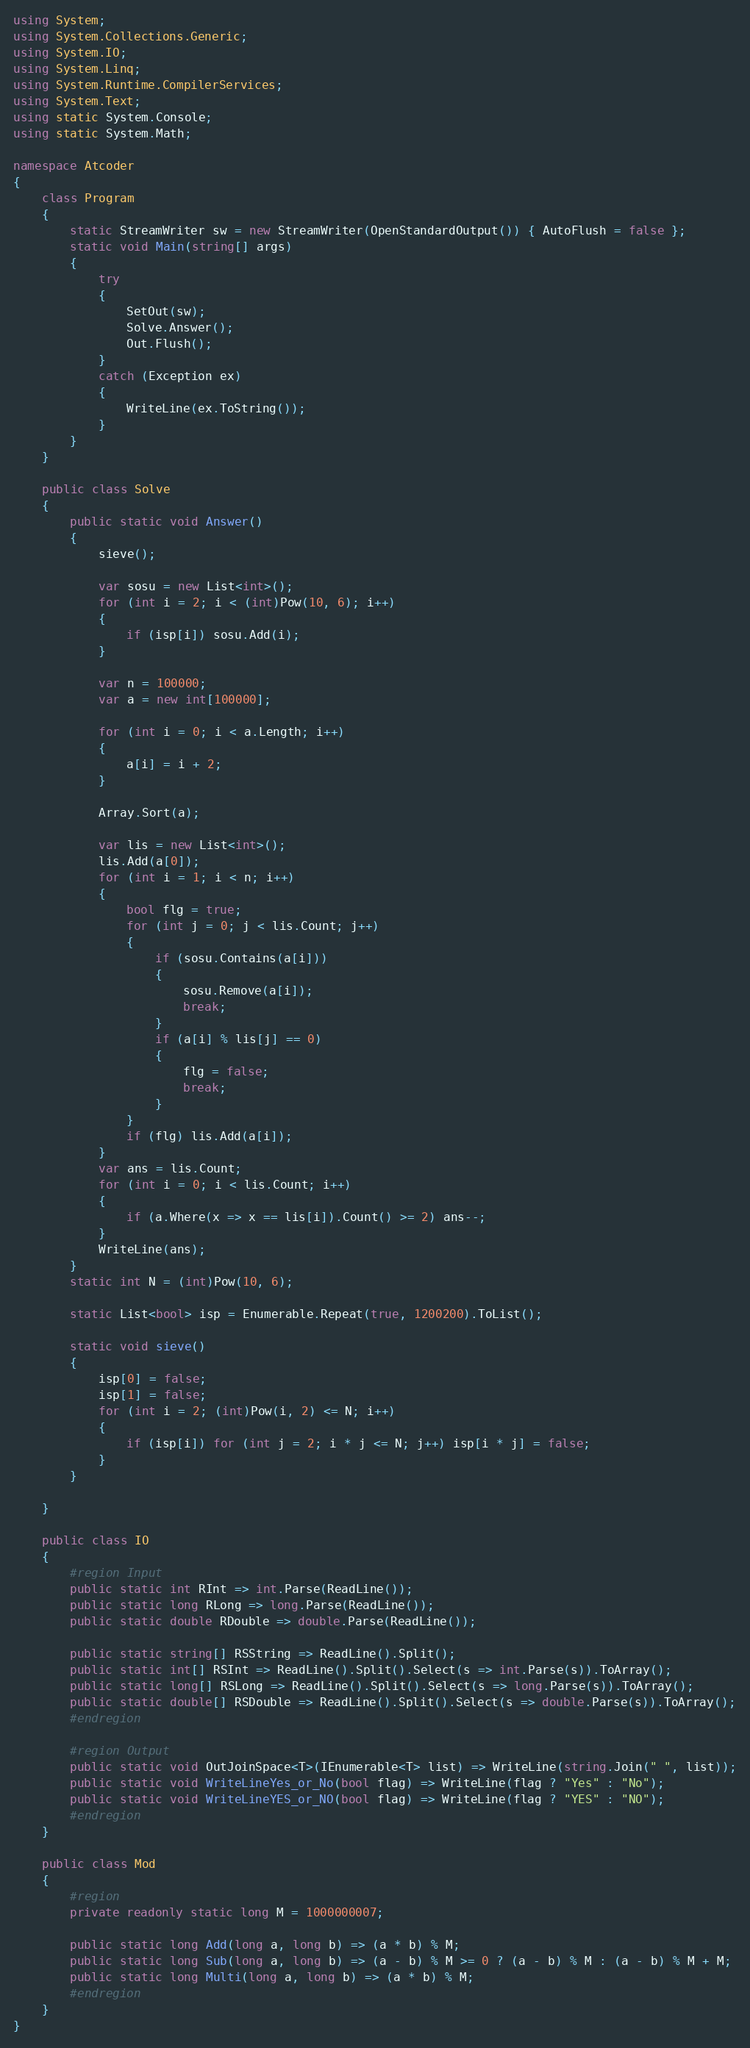Convert code to text. <code><loc_0><loc_0><loc_500><loc_500><_C#_>using System;
using System.Collections.Generic;
using System.IO;
using System.Linq;
using System.Runtime.CompilerServices;
using System.Text;
using static System.Console;
using static System.Math;

namespace Atcoder
{
    class Program
    {
        static StreamWriter sw = new StreamWriter(OpenStandardOutput()) { AutoFlush = false };
        static void Main(string[] args)
        {
            try
            {
                SetOut(sw);
                Solve.Answer();
                Out.Flush();
            }
            catch (Exception ex)
            {
                WriteLine(ex.ToString());
            }
        }
    }

    public class Solve
    {
        public static void Answer()
        {
            sieve();

            var sosu = new List<int>();
            for (int i = 2; i < (int)Pow(10, 6); i++)
            {
                if (isp[i]) sosu.Add(i);
            }

            var n = 100000;
            var a = new int[100000];

            for (int i = 0; i < a.Length; i++)
            {
                a[i] = i + 2;
            }

            Array.Sort(a);

            var lis = new List<int>();
            lis.Add(a[0]);
            for (int i = 1; i < n; i++)
            {
                bool flg = true;
                for (int j = 0; j < lis.Count; j++)
                {
                    if (sosu.Contains(a[i]))
                    {
                        sosu.Remove(a[i]);
                        break;
                    }
                    if (a[i] % lis[j] == 0)
                    {
                        flg = false;
                        break;
                    }
                }
                if (flg) lis.Add(a[i]);
            }
            var ans = lis.Count;
            for (int i = 0; i < lis.Count; i++)
            {
                if (a.Where(x => x == lis[i]).Count() >= 2) ans--;
            }
            WriteLine(ans);
        }
        static int N = (int)Pow(10, 6);

        static List<bool> isp = Enumerable.Repeat(true, 1200200).ToList();

        static void sieve()
        {
            isp[0] = false;
            isp[1] = false;
            for (int i = 2; (int)Pow(i, 2) <= N; i++)
            {
                if (isp[i]) for (int j = 2; i * j <= N; j++) isp[i * j] = false;
            }
        }

    }

    public class IO
    {
        #region Input
        public static int RInt => int.Parse(ReadLine());
        public static long RLong => long.Parse(ReadLine());
        public static double RDouble => double.Parse(ReadLine());

        public static string[] RSString => ReadLine().Split();
        public static int[] RSInt => ReadLine().Split().Select(s => int.Parse(s)).ToArray();
        public static long[] RSLong => ReadLine().Split().Select(s => long.Parse(s)).ToArray();
        public static double[] RSDouble => ReadLine().Split().Select(s => double.Parse(s)).ToArray();
        #endregion

        #region Output
        public static void OutJoinSpace<T>(IEnumerable<T> list) => WriteLine(string.Join(" ", list));
        public static void WriteLineYes_or_No(bool flag) => WriteLine(flag ? "Yes" : "No");
        public static void WriteLineYES_or_NO(bool flag) => WriteLine(flag ? "YES" : "NO");
        #endregion
    }

    public class Mod
    {
        #region
        private readonly static long M = 1000000007;

        public static long Add(long a, long b) => (a * b) % M;
        public static long Sub(long a, long b) => (a - b) % M >= 0 ? (a - b) % M : (a - b) % M + M;
        public static long Multi(long a, long b) => (a * b) % M;
        #endregion
    }
}</code> 